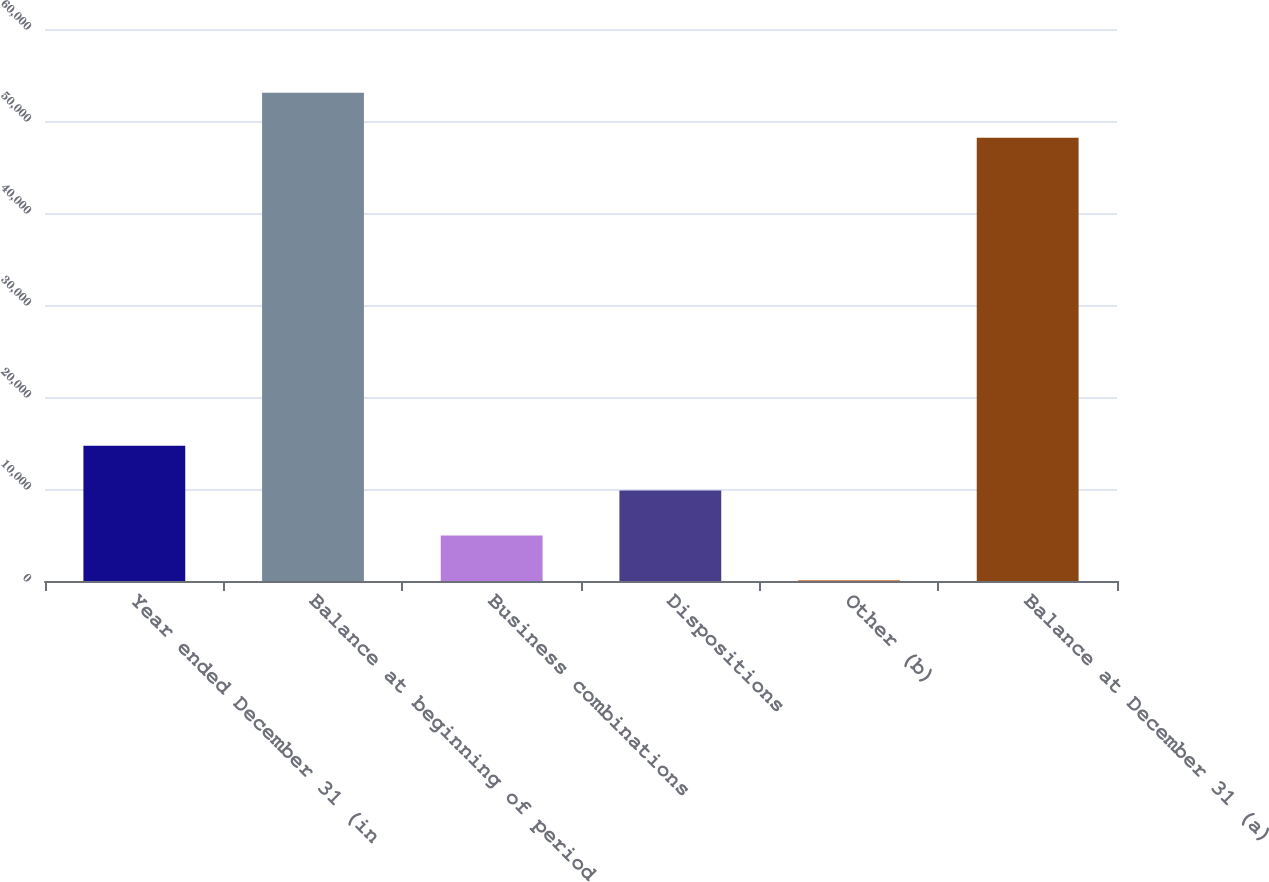Convert chart to OTSL. <chart><loc_0><loc_0><loc_500><loc_500><bar_chart><fcel>Year ended December 31 (in<fcel>Balance at beginning of period<fcel>Business combinations<fcel>Dispositions<fcel>Other (b)<fcel>Balance at December 31 (a)<nl><fcel>14710.8<fcel>53065.6<fcel>4955.6<fcel>9833.2<fcel>78<fcel>48188<nl></chart> 